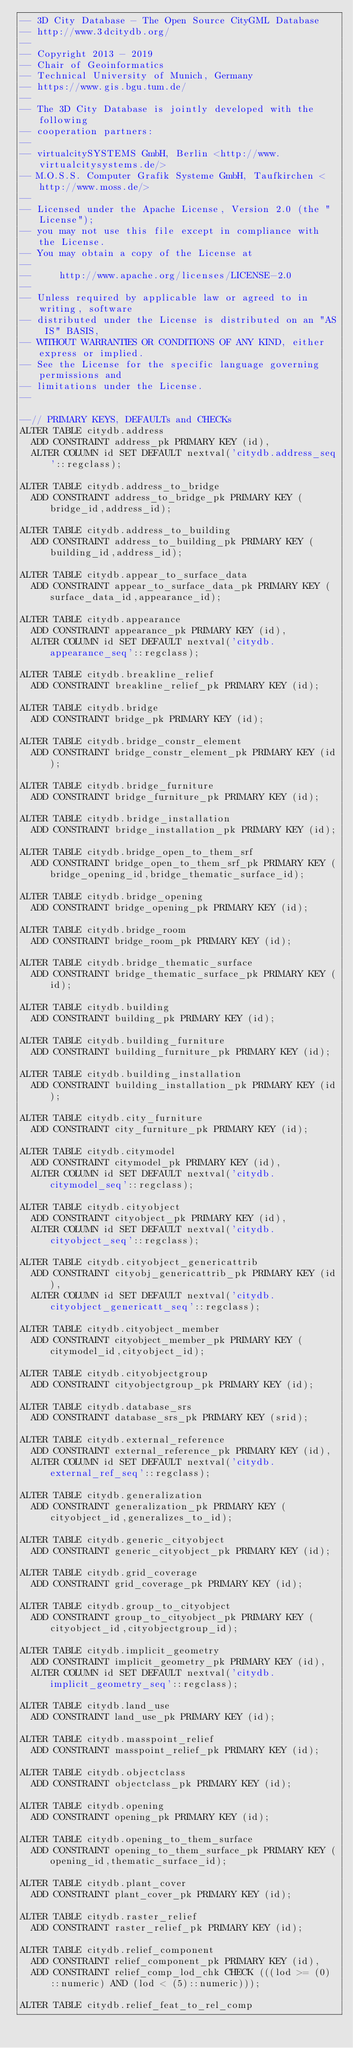Convert code to text. <code><loc_0><loc_0><loc_500><loc_500><_SQL_>-- 3D City Database - The Open Source CityGML Database
-- http://www.3dcitydb.org/
-- 
-- Copyright 2013 - 2019
-- Chair of Geoinformatics
-- Technical University of Munich, Germany
-- https://www.gis.bgu.tum.de/
-- 
-- The 3D City Database is jointly developed with the following
-- cooperation partners:
-- 
-- virtualcitySYSTEMS GmbH, Berlin <http://www.virtualcitysystems.de/>
-- M.O.S.S. Computer Grafik Systeme GmbH, Taufkirchen <http://www.moss.de/>
-- 
-- Licensed under the Apache License, Version 2.0 (the "License");
-- you may not use this file except in compliance with the License.
-- You may obtain a copy of the License at
-- 
--     http://www.apache.org/licenses/LICENSE-2.0
--     
-- Unless required by applicable law or agreed to in writing, software
-- distributed under the License is distributed on an "AS IS" BASIS,
-- WITHOUT WARRANTIES OR CONDITIONS OF ANY KIND, either express or implied.
-- See the License for the specific language governing permissions and
-- limitations under the License.
--

--// PRIMARY KEYS, DEFAULTs and CHECKs
ALTER TABLE citydb.address
  ADD CONSTRAINT address_pk PRIMARY KEY (id),
  ALTER COLUMN id SET DEFAULT nextval('citydb.address_seq'::regclass);

ALTER TABLE citydb.address_to_bridge
  ADD CONSTRAINT address_to_bridge_pk PRIMARY KEY (bridge_id,address_id);

ALTER TABLE citydb.address_to_building
  ADD CONSTRAINT address_to_building_pk PRIMARY KEY (building_id,address_id);

ALTER TABLE citydb.appear_to_surface_data
  ADD CONSTRAINT appear_to_surface_data_pk PRIMARY KEY (surface_data_id,appearance_id);

ALTER TABLE citydb.appearance
  ADD CONSTRAINT appearance_pk PRIMARY KEY (id),
  ALTER COLUMN id SET DEFAULT nextval('citydb.appearance_seq'::regclass);

ALTER TABLE citydb.breakline_relief
  ADD CONSTRAINT breakline_relief_pk PRIMARY KEY (id);

ALTER TABLE citydb.bridge
  ADD CONSTRAINT bridge_pk PRIMARY KEY (id);

ALTER TABLE citydb.bridge_constr_element
  ADD CONSTRAINT bridge_constr_element_pk PRIMARY KEY (id);

ALTER TABLE citydb.bridge_furniture
  ADD CONSTRAINT bridge_furniture_pk PRIMARY KEY (id);

ALTER TABLE citydb.bridge_installation
  ADD CONSTRAINT bridge_installation_pk PRIMARY KEY (id);

ALTER TABLE citydb.bridge_open_to_them_srf
  ADD CONSTRAINT bridge_open_to_them_srf_pk PRIMARY KEY (bridge_opening_id,bridge_thematic_surface_id);

ALTER TABLE citydb.bridge_opening
  ADD CONSTRAINT bridge_opening_pk PRIMARY KEY (id);

ALTER TABLE citydb.bridge_room
  ADD CONSTRAINT bridge_room_pk PRIMARY KEY (id);

ALTER TABLE citydb.bridge_thematic_surface
  ADD CONSTRAINT bridge_thematic_surface_pk PRIMARY KEY (id);

ALTER TABLE citydb.building
  ADD CONSTRAINT building_pk PRIMARY KEY (id);

ALTER TABLE citydb.building_furniture
  ADD CONSTRAINT building_furniture_pk PRIMARY KEY (id);

ALTER TABLE citydb.building_installation
  ADD CONSTRAINT building_installation_pk PRIMARY KEY (id);

ALTER TABLE citydb.city_furniture
  ADD CONSTRAINT city_furniture_pk PRIMARY KEY (id);

ALTER TABLE citydb.citymodel
  ADD CONSTRAINT citymodel_pk PRIMARY KEY (id),
  ALTER COLUMN id SET DEFAULT nextval('citydb.citymodel_seq'::regclass);

ALTER TABLE citydb.cityobject
  ADD CONSTRAINT cityobject_pk PRIMARY KEY (id),
  ALTER COLUMN id SET DEFAULT nextval('citydb.cityobject_seq'::regclass);

ALTER TABLE citydb.cityobject_genericattrib
  ADD CONSTRAINT cityobj_genericattrib_pk PRIMARY KEY (id),
  ALTER COLUMN id SET DEFAULT nextval('citydb.cityobject_genericatt_seq'::regclass);

ALTER TABLE citydb.cityobject_member
  ADD CONSTRAINT cityobject_member_pk PRIMARY KEY (citymodel_id,cityobject_id);

ALTER TABLE citydb.cityobjectgroup
  ADD CONSTRAINT cityobjectgroup_pk PRIMARY KEY (id);

ALTER TABLE citydb.database_srs
  ADD CONSTRAINT database_srs_pk PRIMARY KEY (srid);

ALTER TABLE citydb.external_reference
  ADD CONSTRAINT external_reference_pk PRIMARY KEY (id),
  ALTER COLUMN id SET DEFAULT nextval('citydb.external_ref_seq'::regclass);

ALTER TABLE citydb.generalization
  ADD CONSTRAINT generalization_pk PRIMARY KEY (cityobject_id,generalizes_to_id);

ALTER TABLE citydb.generic_cityobject
  ADD CONSTRAINT generic_cityobject_pk PRIMARY KEY (id);

ALTER TABLE citydb.grid_coverage
  ADD CONSTRAINT grid_coverage_pk PRIMARY KEY (id);

ALTER TABLE citydb.group_to_cityobject
  ADD CONSTRAINT group_to_cityobject_pk PRIMARY KEY (cityobject_id,cityobjectgroup_id);

ALTER TABLE citydb.implicit_geometry
  ADD CONSTRAINT implicit_geometry_pk PRIMARY KEY (id),
  ALTER COLUMN id SET DEFAULT nextval('citydb.implicit_geometry_seq'::regclass);
  
ALTER TABLE citydb.land_use
  ADD CONSTRAINT land_use_pk PRIMARY KEY (id);

ALTER TABLE citydb.masspoint_relief
  ADD CONSTRAINT masspoint_relief_pk PRIMARY KEY (id);

ALTER TABLE citydb.objectclass
  ADD CONSTRAINT objectclass_pk PRIMARY KEY (id);

ALTER TABLE citydb.opening
  ADD CONSTRAINT opening_pk PRIMARY KEY (id);

ALTER TABLE citydb.opening_to_them_surface
  ADD CONSTRAINT opening_to_them_surface_pk PRIMARY KEY (opening_id,thematic_surface_id);

ALTER TABLE citydb.plant_cover
  ADD CONSTRAINT plant_cover_pk PRIMARY KEY (id);

ALTER TABLE citydb.raster_relief
  ADD CONSTRAINT raster_relief_pk PRIMARY KEY (id);

ALTER TABLE citydb.relief_component
  ADD CONSTRAINT relief_component_pk PRIMARY KEY (id),
  ADD CONSTRAINT relief_comp_lod_chk CHECK (((lod >= (0)::numeric) AND (lod < (5)::numeric)));

ALTER TABLE citydb.relief_feat_to_rel_comp</code> 